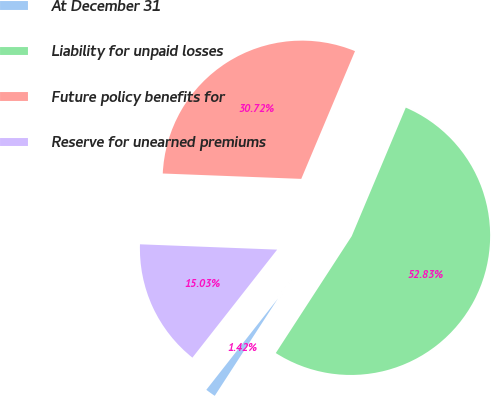<chart> <loc_0><loc_0><loc_500><loc_500><pie_chart><fcel>At December 31<fcel>Liability for unpaid losses<fcel>Future policy benefits for<fcel>Reserve for unearned premiums<nl><fcel>1.42%<fcel>52.83%<fcel>30.72%<fcel>15.03%<nl></chart> 